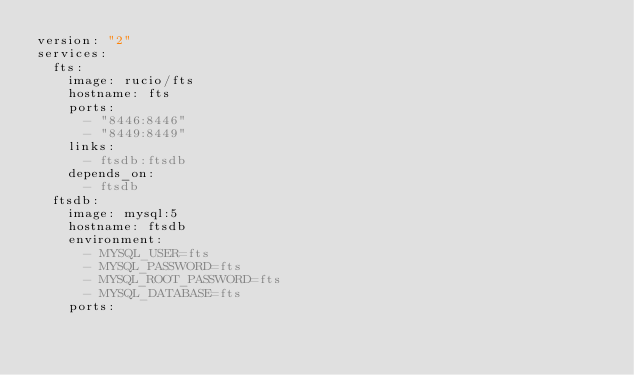<code> <loc_0><loc_0><loc_500><loc_500><_YAML_>version: "2"
services:
  fts:
    image: rucio/fts
    hostname: fts
    ports:
      - "8446:8446"
      - "8449:8449"
    links:
      - ftsdb:ftsdb
    depends_on:
      - ftsdb
  ftsdb:
    image: mysql:5
    hostname: ftsdb
    environment:
      - MYSQL_USER=fts
      - MYSQL_PASSWORD=fts
      - MYSQL_ROOT_PASSWORD=fts
      - MYSQL_DATABASE=fts
    ports:</code> 